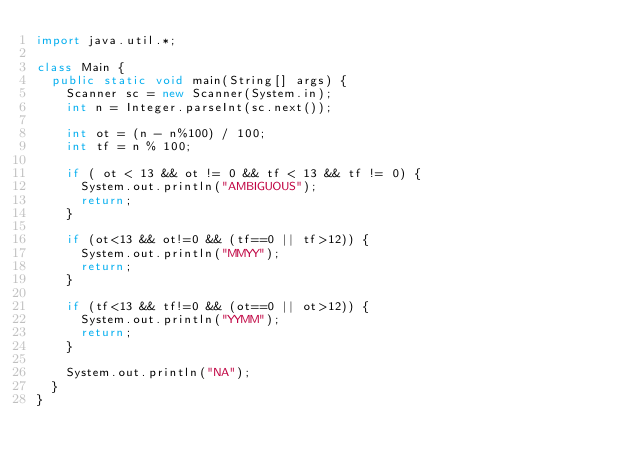Convert code to text. <code><loc_0><loc_0><loc_500><loc_500><_Java_>import java.util.*;

class Main {
  public static void main(String[] args) {
    Scanner sc = new Scanner(System.in);
    int n = Integer.parseInt(sc.next());
    
    int ot = (n - n%100) / 100;
    int tf = n % 100;
    
	if ( ot < 13 && ot != 0 && tf < 13 && tf != 0) {
      System.out.println("AMBIGUOUS");
      return;
    }
    
    if (ot<13 && ot!=0 && (tf==0 || tf>12)) {
      System.out.println("MMYY");
      return;
    }
    
    if (tf<13 && tf!=0 && (ot==0 || ot>12)) {
      System.out.println("YYMM");
      return;
    }
    
    System.out.println("NA");
  }
}
</code> 